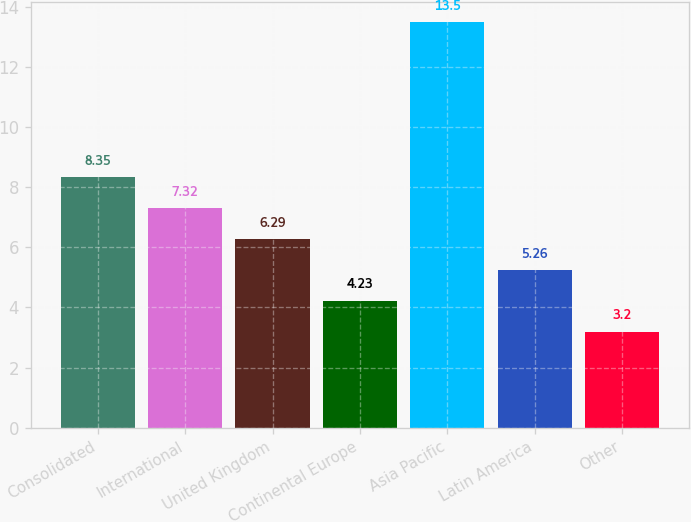<chart> <loc_0><loc_0><loc_500><loc_500><bar_chart><fcel>Consolidated<fcel>International<fcel>United Kingdom<fcel>Continental Europe<fcel>Asia Pacific<fcel>Latin America<fcel>Other<nl><fcel>8.35<fcel>7.32<fcel>6.29<fcel>4.23<fcel>13.5<fcel>5.26<fcel>3.2<nl></chart> 